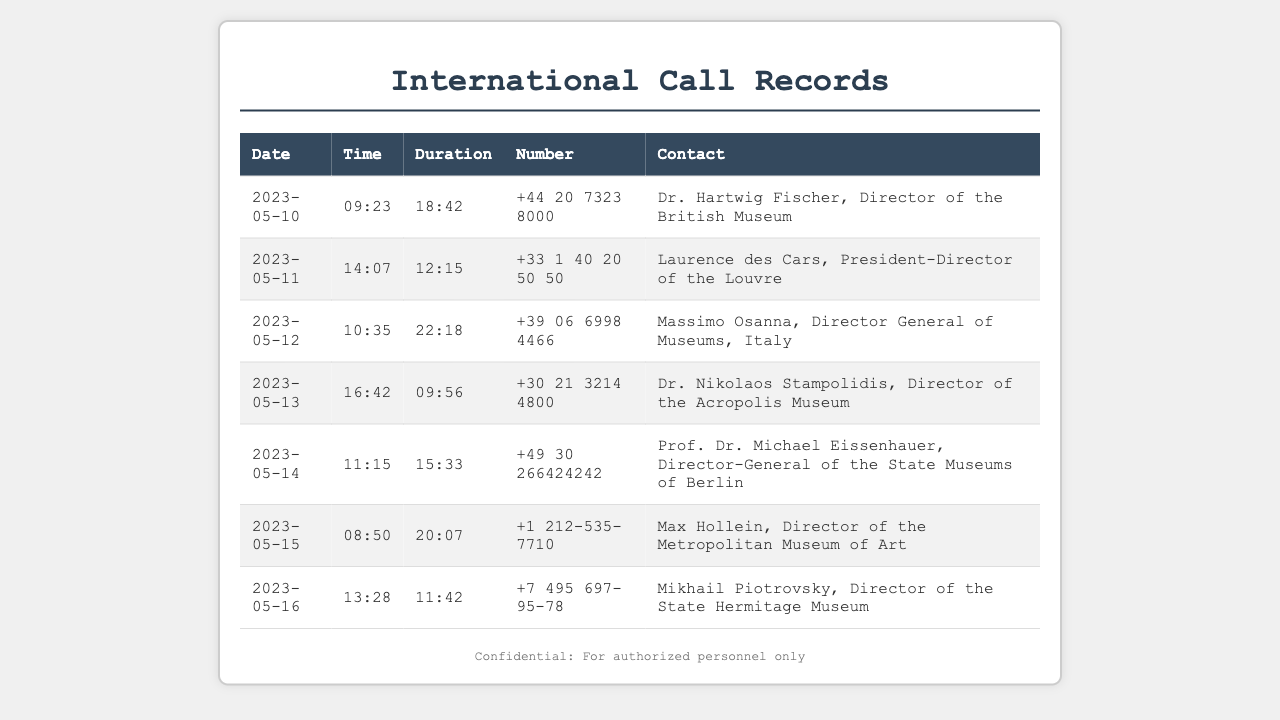What is the duration of the call to Max Hollein? The duration is found in the row corresponding to Max Hollein's call, which is 20:07.
Answer: 20:07 Who is the Director of the Acropolis Museum? The document lists Dr. Nikolaos Stampolidis as the contact for the Acropolis Museum.
Answer: Dr. Nikolaos Stampolidis When did the call to Laurence des Cars take place? The date of the call can be found in the row for Laurence des Cars, which is 2023-05-11.
Answer: 2023-05-11 What time was the call to the State Hermitage Museum? The time of the call is recorded in the row for Mikhail Piotrovsky, which is 13:28.
Answer: 13:28 How many minutes did the call to Massimo Osanna last? The call duration is listed in the row for Massimo Osanna, which is 22:18; this indicates the minutes.
Answer: 22:18 Which museum does Prof. Dr. Michael Eissenhauer represent? The document provides the title of Prof. Dr. Michael Eissenhauer as the Director-General of the State Museums of Berlin.
Answer: State Museums of Berlin Who was contacted on May 12, 2023? The entry details for May 12 show that the contact was Massimo Osanna.
Answer: Massimo Osanna What type of document is this? The structure and information presented indicate that the document is a record of telephone calls.
Answer: Telephone records 